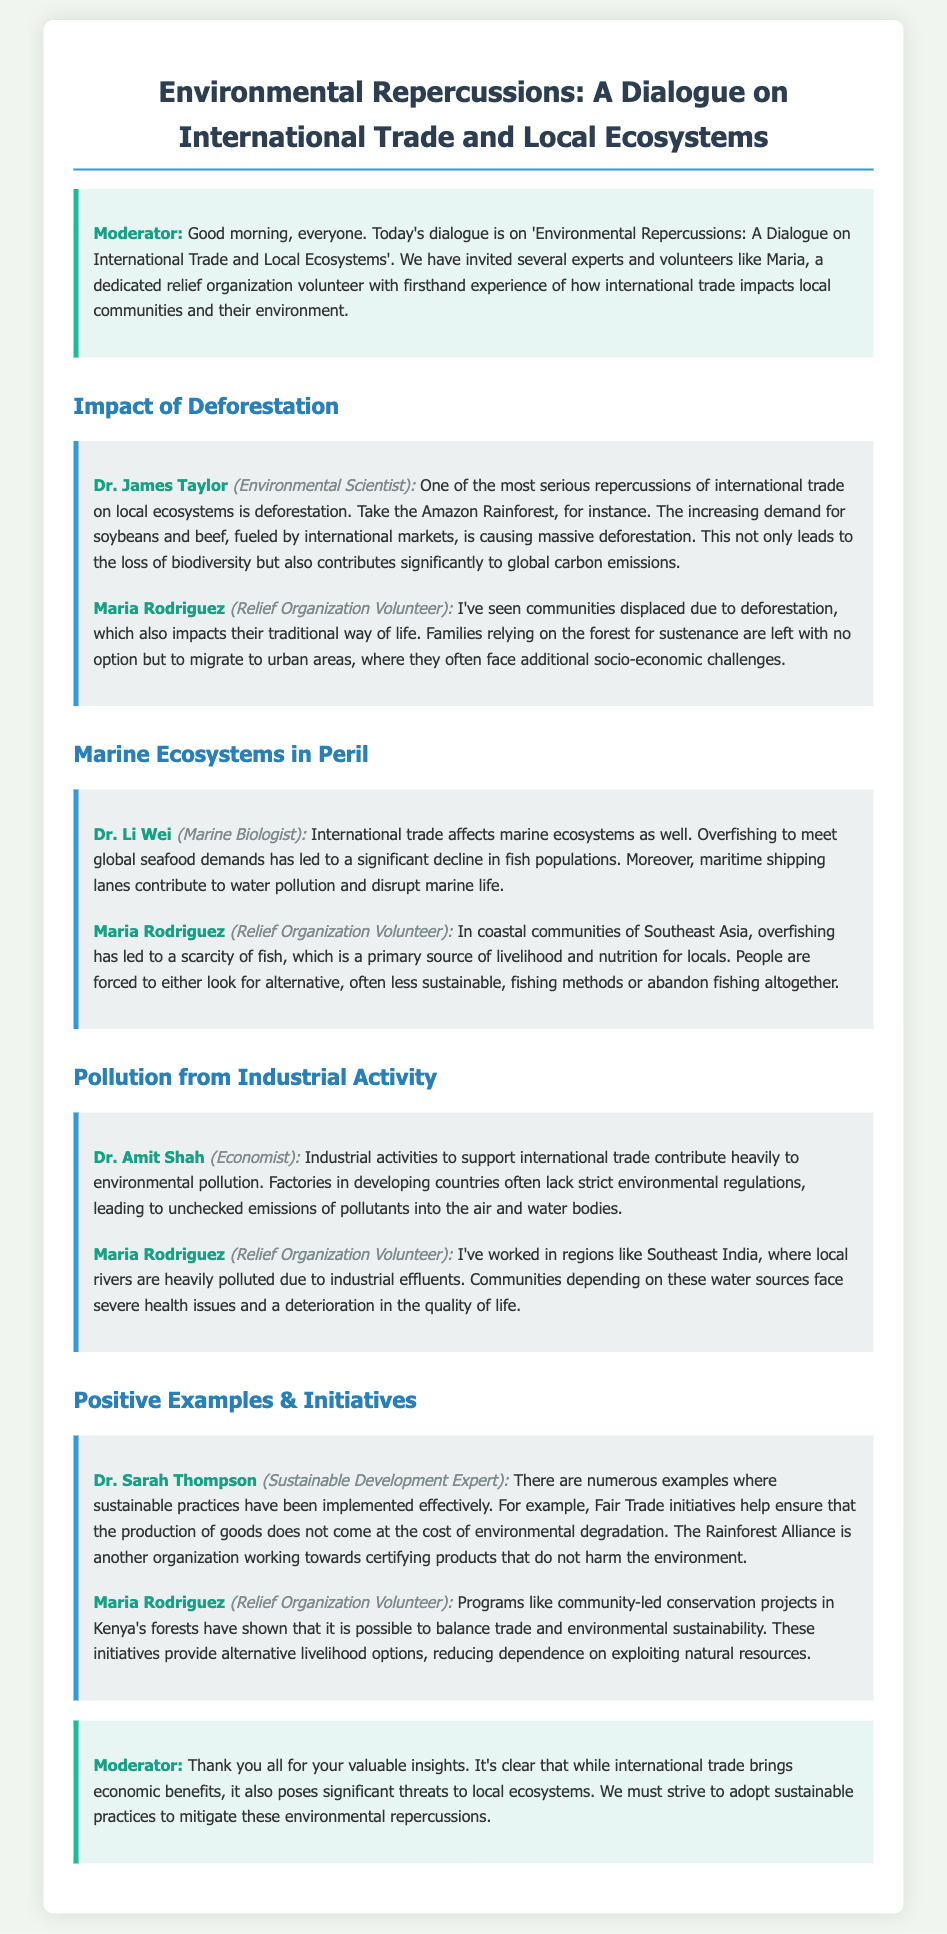What is one major consequence of international trade discussed in the document? The document highlights deforestation as a significant consequence of international trade, particularly in the Amazon Rainforest.
Answer: Deforestation Who is the Marine Biologist contributing to the dialogue? Dr. Li Wei is identified as the Marine Biologist in the dialogue.
Answer: Dr. Li Wei What has led to the displacement of communities according to Maria? Maria mentions that communities are displaced due to deforestation affecting their traditional way of life.
Answer: Deforestation Which organization certifies products that do not harm the environment? The Rainforest Alliance is mentioned as an organization that certifies such products.
Answer: Rainforest Alliance What health issue do communities face from industrial pollution as noted by Maria? Maria indicates that communities depending on polluted water sources face severe health issues.
Answer: Health issues What is one positive initiative mentioned that helps balance trade and environmental sustainability? Community-led conservation projects in Kenya's forests are cited as a positive initiative.
Answer: Community-led conservation projects Who expressed concerns about industrial pollution in the dialogue? Dr. Amit Shah expressed concerns about pollution from industrial activities supporting international trade.
Answer: Dr. Amit Shah What is the primary source of livelihood for coastal communities, as noted by Maria? Maria states that fish is the primary source of livelihood for coastal communities.
Answer: Fish 